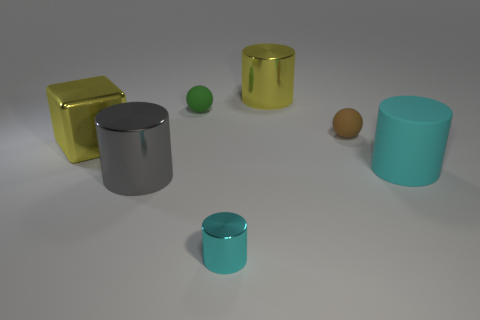Can you describe the lighting and its effect on the scene? The lighting in the scene appears to be soft and diffused, coming from a source above and leading to gentle shadows beneath each object. This sort of illumination accentuates the form of the objects and their positions relative to one another, without creating harsh highlights or deep shadows. It offers a serene atmosphere and allows the intrinsic colors and materials of the objects to be appreciated. 